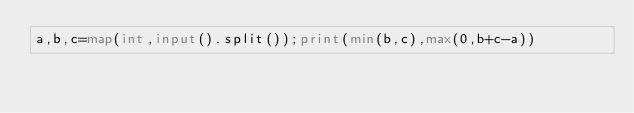Convert code to text. <code><loc_0><loc_0><loc_500><loc_500><_Python_>a,b,c=map(int,input().split());print(min(b,c),max(0,b+c-a))</code> 